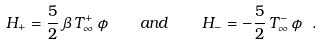<formula> <loc_0><loc_0><loc_500><loc_500>H _ { + } = \frac { 5 } { 2 } \, \beta \, T _ { \infty } ^ { + } \, \phi \quad a n d \quad H _ { - } = - \frac { 5 } { 2 } \, T _ { \infty } ^ { - } \, \phi \ .</formula> 